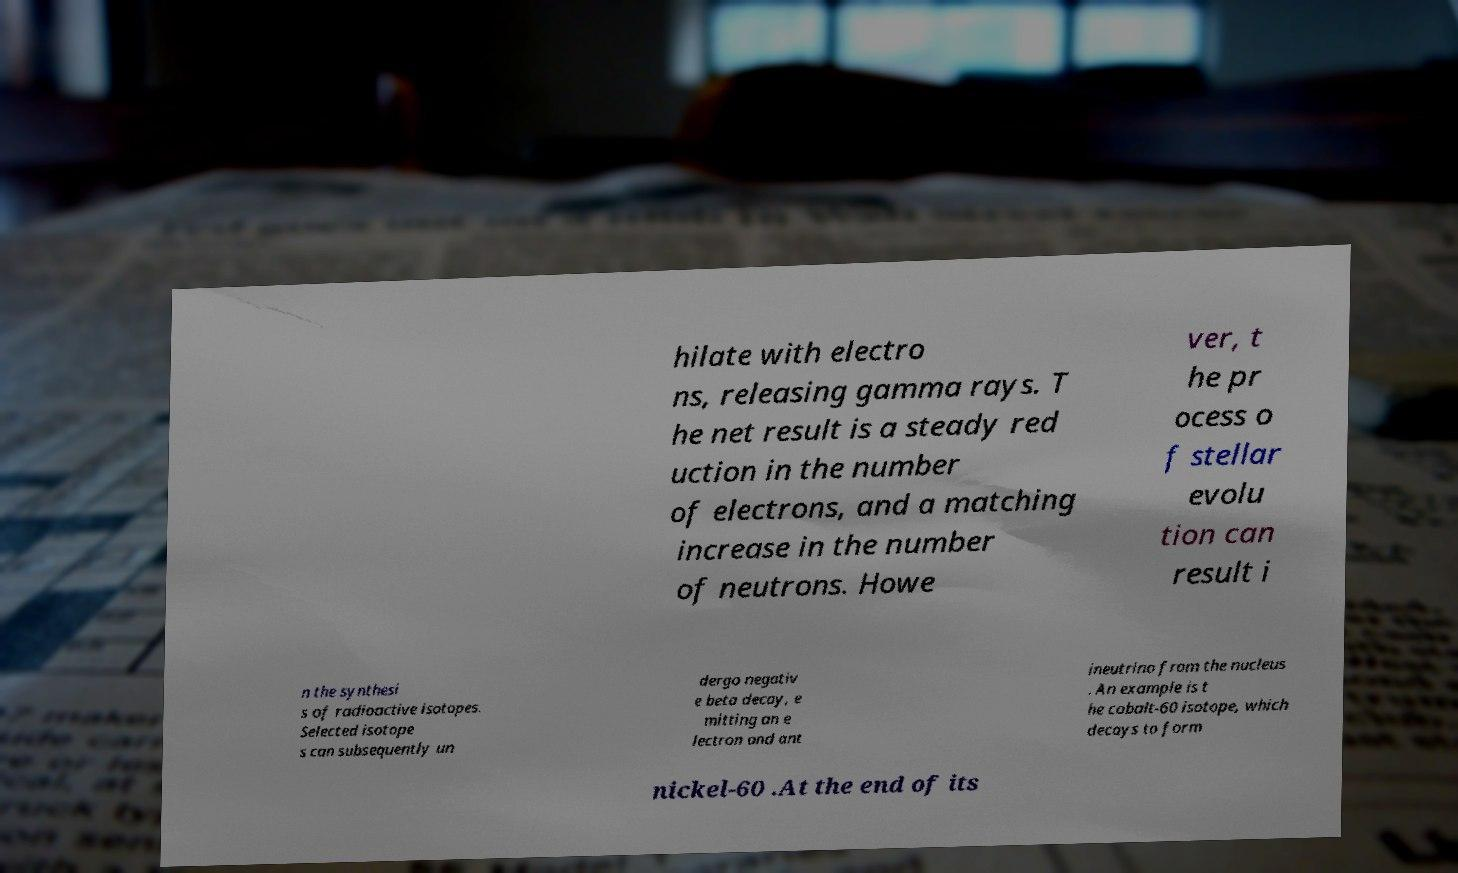Could you extract and type out the text from this image? hilate with electro ns, releasing gamma rays. T he net result is a steady red uction in the number of electrons, and a matching increase in the number of neutrons. Howe ver, t he pr ocess o f stellar evolu tion can result i n the synthesi s of radioactive isotopes. Selected isotope s can subsequently un dergo negativ e beta decay, e mitting an e lectron and ant ineutrino from the nucleus . An example is t he cobalt-60 isotope, which decays to form nickel-60 .At the end of its 